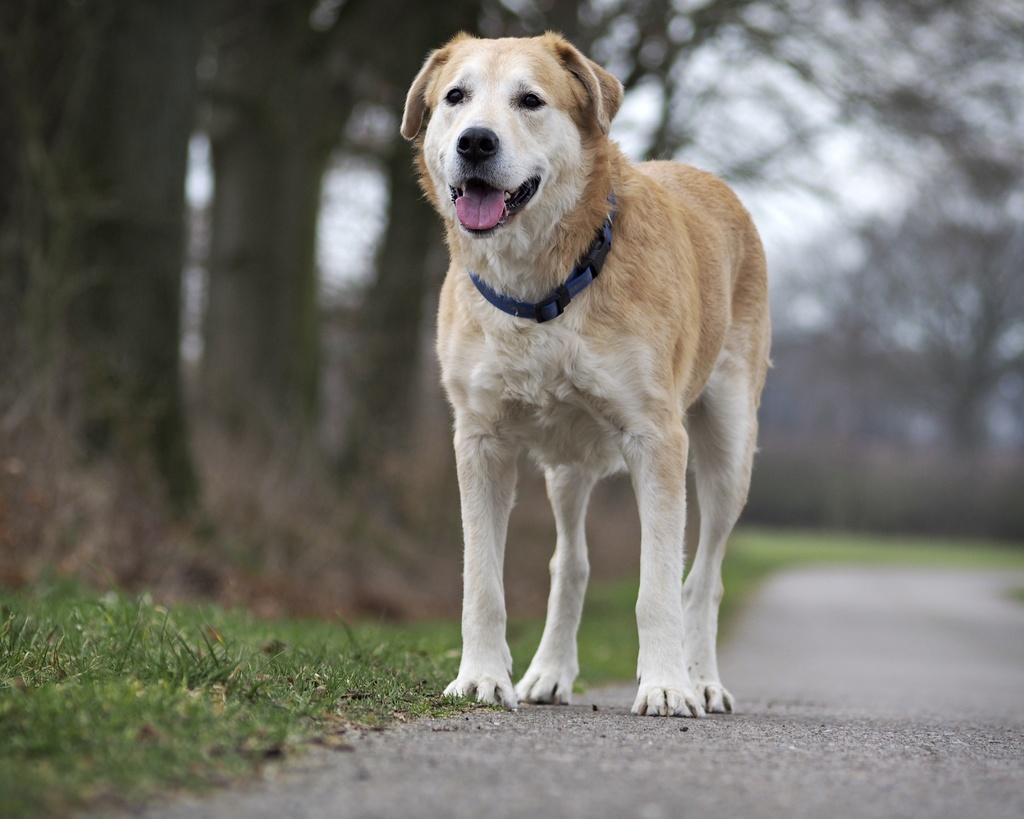What animal can be seen in the picture? There is a dog in the picture. What is the dog doing in the picture? The dog is standing. What type of vegetation is on the left side of the picture? There is grass on the left side of the picture. What else can be seen on the left side of the picture? There are trees on the left side of the picture. What is the condition of the sky in the picture? The sky is clear in the picture. How many spiders are crawling on the dog in the image? There are no spiders visible on the dog in the image. What type of metal object can be seen near the dog in the image? There is no metal object present near the dog in the image. 